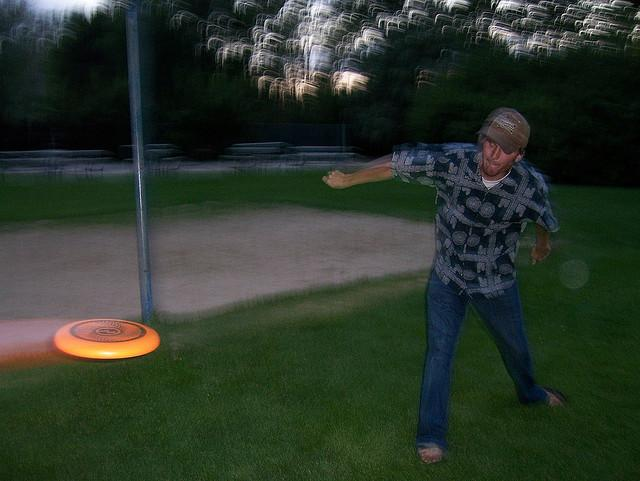In which type space does this man spin his frisbee? Please explain your reasoning. park. The space is a park. 